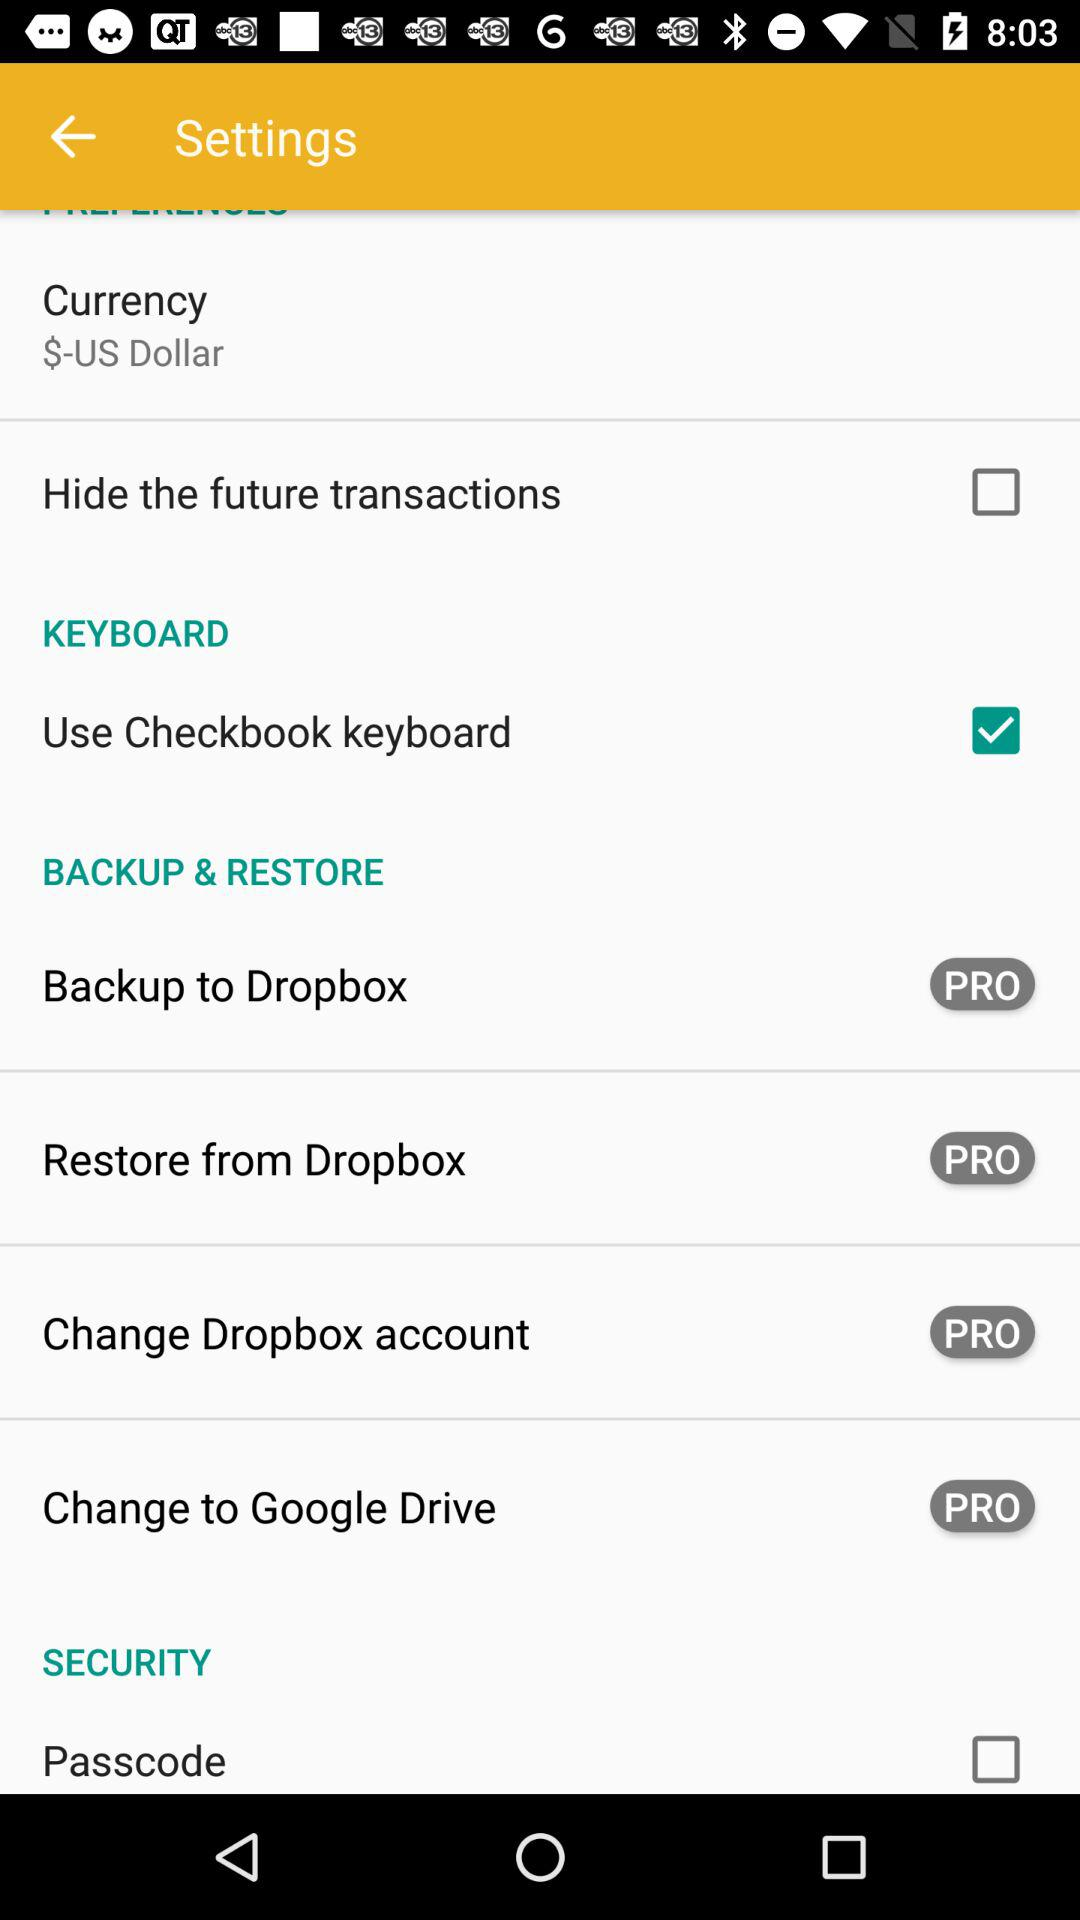What is the status of "Hide the future transactions"? The status is "off". 